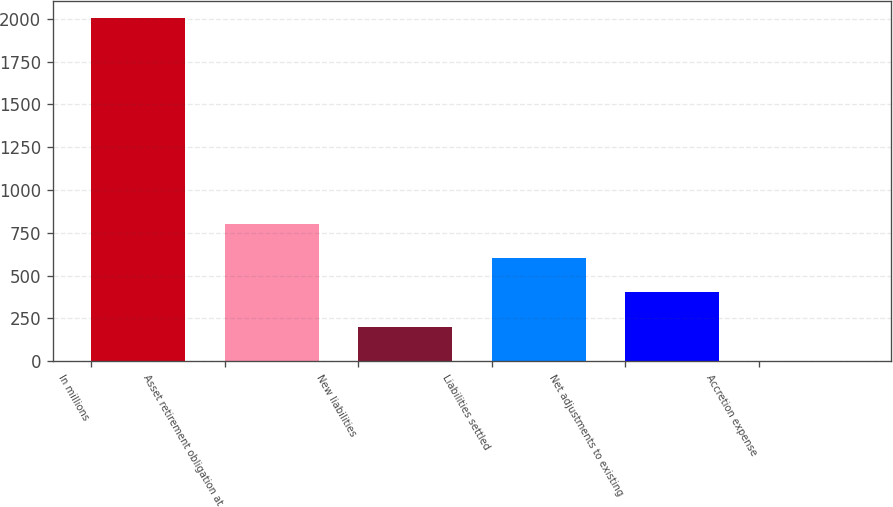<chart> <loc_0><loc_0><loc_500><loc_500><bar_chart><fcel>In millions<fcel>Asset retirement obligation at<fcel>New liabilities<fcel>Liabilities settled<fcel>Net adjustments to existing<fcel>Accretion expense<nl><fcel>2004<fcel>802.2<fcel>201.3<fcel>601.9<fcel>401.6<fcel>1<nl></chart> 